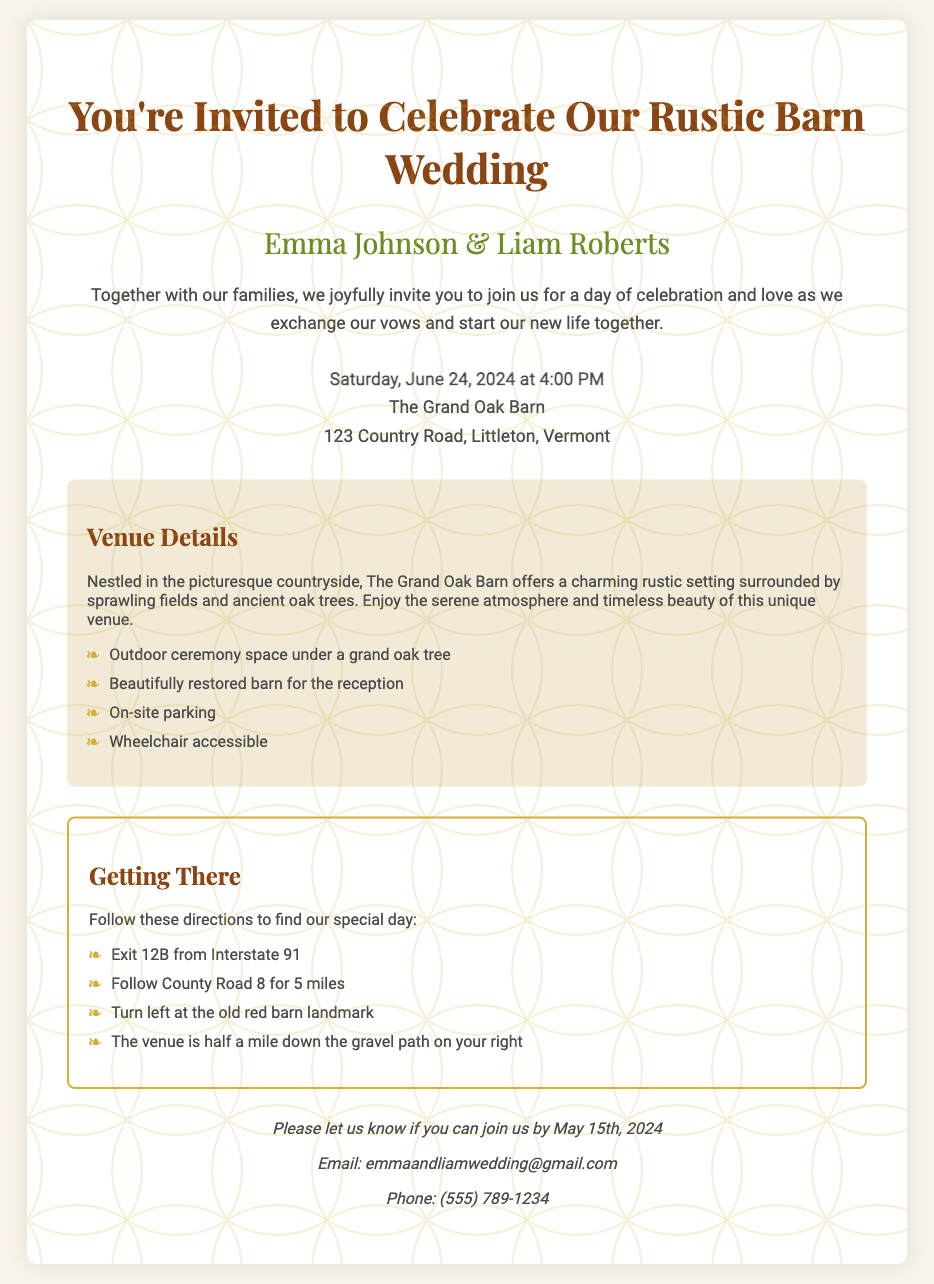What is the date of the wedding? The wedding is scheduled for Saturday, June 24, 2024, as stated in the invitation text.
Answer: June 24, 2024 Who are the couple getting married? The couple's names are mentioned in the invitation as Emma Johnson and Liam Roberts.
Answer: Emma Johnson & Liam Roberts Where will the wedding take place? The venue details indicate that the wedding will be held at The Grand Oak Barn, located at 123 Country Road, Littleton, Vermont.
Answer: The Grand Oak Barn What is one feature of the venue mentioned? The document lists several features, one of which is an outdoor ceremony space under a grand oak tree.
Answer: Outdoor ceremony space under a grand oak tree By what date should guests RSVP? The RSVP section of the invitation specifies that guests should respond by May 15th, 2024.
Answer: May 15th, 2024 What should guests do to reach the venue? The 'Getting There' section provides directions, emphasizing the exit from Interstate 91 as the starting point for guests.
Answer: Exit 12B from Interstate 91 Is there on-site parking available? The venue details explicitly mention on-site parking as one of the amenities provided for guests.
Answer: Yes What type of map is included for navigation? The document includes a hand-drawn map designed to assist guests with navigation to the wedding venue.
Answer: Hand-drawn map 